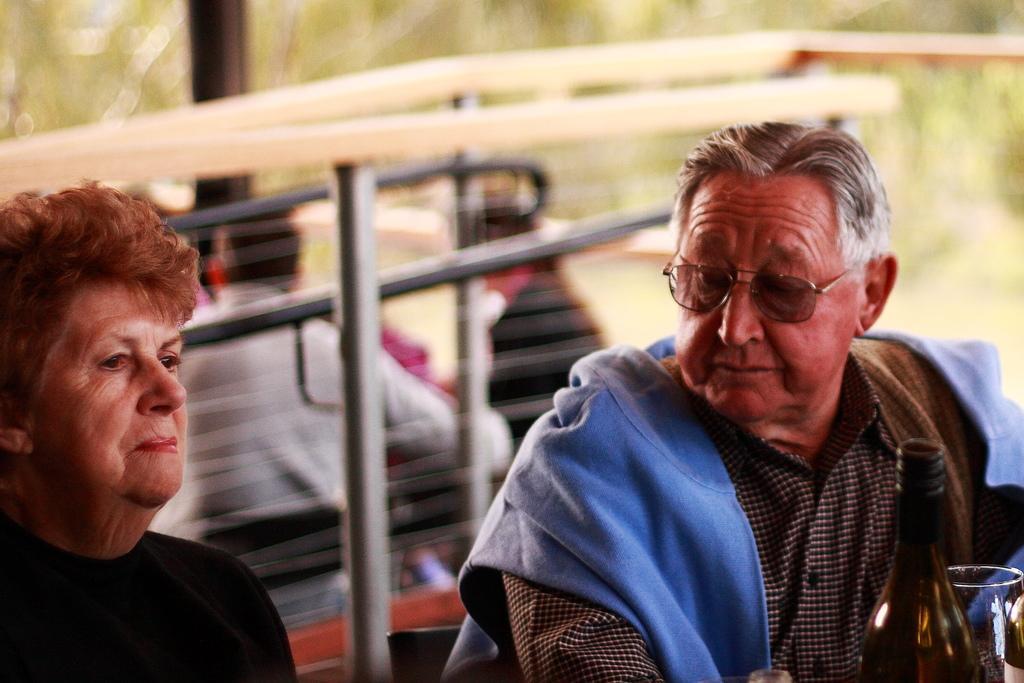In one or two sentences, can you explain what this image depicts? In the center of the image there are two persons. There is a bottle. There is a glass. In the background of the image there are persons. There are rods. 